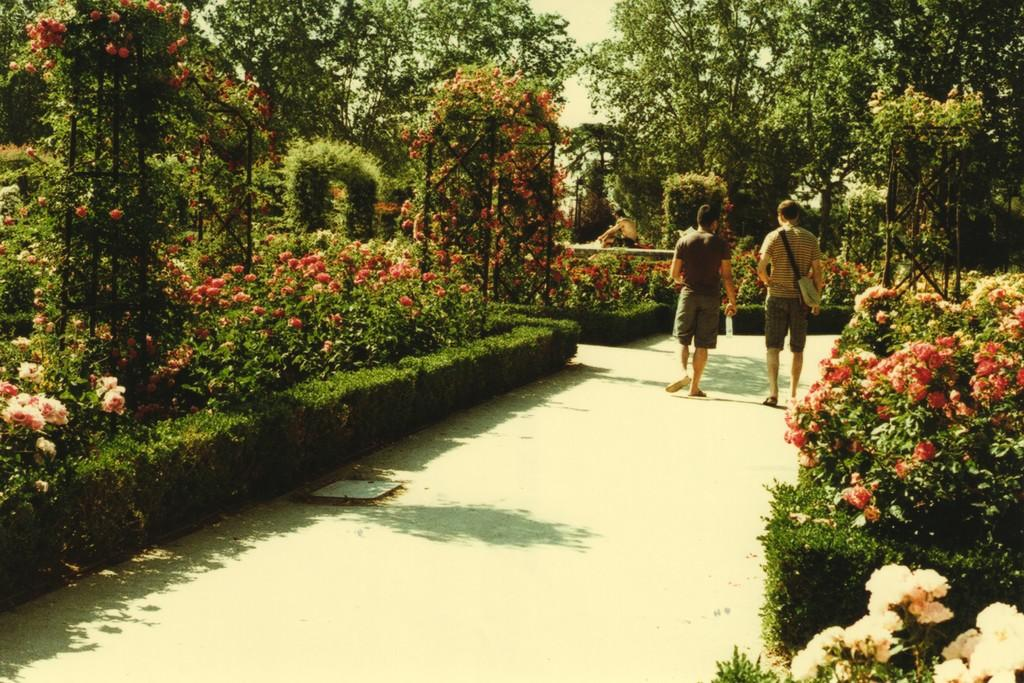How many people are in the image? There are two men in the image. What are the men doing in the image? The men are walking on a road. What can be seen on either side of the road? There are plants and shrubs on either side of the road. What is visible in the background of the image? There are trees in the background of the image. Where might this image have been taken? The image might have been taken in a garden, given the presence of plants, shrubs, and trees. What type of substance is being used to write on the trees in the image? There is no indication in the image that anyone is writing on the trees, and therefore no such substance can be identified. 